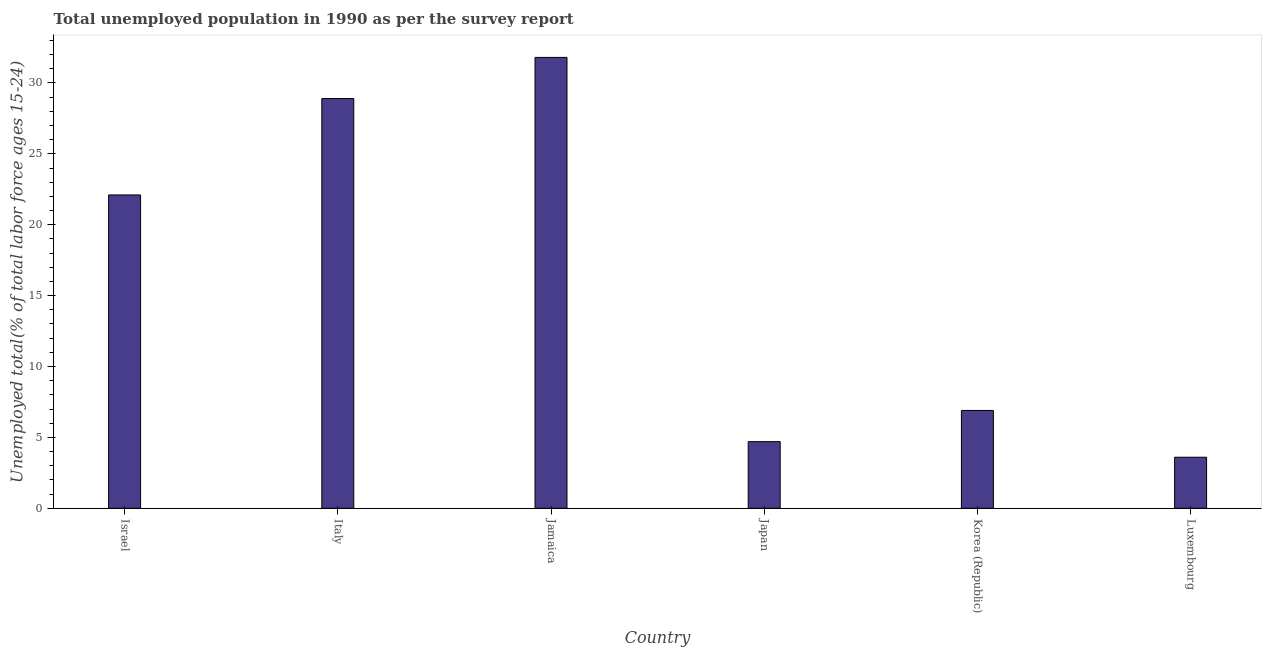Does the graph contain any zero values?
Your answer should be compact. No. Does the graph contain grids?
Your answer should be very brief. No. What is the title of the graph?
Provide a succinct answer. Total unemployed population in 1990 as per the survey report. What is the label or title of the X-axis?
Keep it short and to the point. Country. What is the label or title of the Y-axis?
Your response must be concise. Unemployed total(% of total labor force ages 15-24). What is the unemployed youth in Jamaica?
Provide a short and direct response. 31.8. Across all countries, what is the maximum unemployed youth?
Ensure brevity in your answer.  31.8. Across all countries, what is the minimum unemployed youth?
Provide a succinct answer. 3.6. In which country was the unemployed youth maximum?
Keep it short and to the point. Jamaica. In which country was the unemployed youth minimum?
Your answer should be very brief. Luxembourg. What is the sum of the unemployed youth?
Your response must be concise. 98. What is the difference between the unemployed youth in Japan and Korea (Republic)?
Your answer should be compact. -2.2. What is the average unemployed youth per country?
Your response must be concise. 16.33. What is the median unemployed youth?
Give a very brief answer. 14.5. What is the ratio of the unemployed youth in Italy to that in Korea (Republic)?
Your answer should be very brief. 4.19. Is the unemployed youth in Italy less than that in Japan?
Ensure brevity in your answer.  No. Is the difference between the unemployed youth in Israel and Korea (Republic) greater than the difference between any two countries?
Offer a terse response. No. What is the difference between the highest and the second highest unemployed youth?
Make the answer very short. 2.9. What is the difference between the highest and the lowest unemployed youth?
Provide a succinct answer. 28.2. In how many countries, is the unemployed youth greater than the average unemployed youth taken over all countries?
Provide a succinct answer. 3. How many bars are there?
Ensure brevity in your answer.  6. What is the Unemployed total(% of total labor force ages 15-24) of Israel?
Keep it short and to the point. 22.1. What is the Unemployed total(% of total labor force ages 15-24) in Italy?
Give a very brief answer. 28.9. What is the Unemployed total(% of total labor force ages 15-24) in Jamaica?
Give a very brief answer. 31.8. What is the Unemployed total(% of total labor force ages 15-24) in Japan?
Make the answer very short. 4.7. What is the Unemployed total(% of total labor force ages 15-24) of Korea (Republic)?
Your answer should be very brief. 6.9. What is the Unemployed total(% of total labor force ages 15-24) of Luxembourg?
Keep it short and to the point. 3.6. What is the difference between the Unemployed total(% of total labor force ages 15-24) in Israel and Italy?
Your response must be concise. -6.8. What is the difference between the Unemployed total(% of total labor force ages 15-24) in Israel and Jamaica?
Keep it short and to the point. -9.7. What is the difference between the Unemployed total(% of total labor force ages 15-24) in Israel and Korea (Republic)?
Offer a terse response. 15.2. What is the difference between the Unemployed total(% of total labor force ages 15-24) in Italy and Japan?
Ensure brevity in your answer.  24.2. What is the difference between the Unemployed total(% of total labor force ages 15-24) in Italy and Luxembourg?
Offer a very short reply. 25.3. What is the difference between the Unemployed total(% of total labor force ages 15-24) in Jamaica and Japan?
Your response must be concise. 27.1. What is the difference between the Unemployed total(% of total labor force ages 15-24) in Jamaica and Korea (Republic)?
Keep it short and to the point. 24.9. What is the difference between the Unemployed total(% of total labor force ages 15-24) in Jamaica and Luxembourg?
Offer a very short reply. 28.2. What is the ratio of the Unemployed total(% of total labor force ages 15-24) in Israel to that in Italy?
Your answer should be compact. 0.77. What is the ratio of the Unemployed total(% of total labor force ages 15-24) in Israel to that in Jamaica?
Provide a short and direct response. 0.69. What is the ratio of the Unemployed total(% of total labor force ages 15-24) in Israel to that in Japan?
Offer a very short reply. 4.7. What is the ratio of the Unemployed total(% of total labor force ages 15-24) in Israel to that in Korea (Republic)?
Your answer should be very brief. 3.2. What is the ratio of the Unemployed total(% of total labor force ages 15-24) in Israel to that in Luxembourg?
Your answer should be compact. 6.14. What is the ratio of the Unemployed total(% of total labor force ages 15-24) in Italy to that in Jamaica?
Your response must be concise. 0.91. What is the ratio of the Unemployed total(% of total labor force ages 15-24) in Italy to that in Japan?
Provide a succinct answer. 6.15. What is the ratio of the Unemployed total(% of total labor force ages 15-24) in Italy to that in Korea (Republic)?
Provide a short and direct response. 4.19. What is the ratio of the Unemployed total(% of total labor force ages 15-24) in Italy to that in Luxembourg?
Keep it short and to the point. 8.03. What is the ratio of the Unemployed total(% of total labor force ages 15-24) in Jamaica to that in Japan?
Offer a very short reply. 6.77. What is the ratio of the Unemployed total(% of total labor force ages 15-24) in Jamaica to that in Korea (Republic)?
Make the answer very short. 4.61. What is the ratio of the Unemployed total(% of total labor force ages 15-24) in Jamaica to that in Luxembourg?
Your response must be concise. 8.83. What is the ratio of the Unemployed total(% of total labor force ages 15-24) in Japan to that in Korea (Republic)?
Ensure brevity in your answer.  0.68. What is the ratio of the Unemployed total(% of total labor force ages 15-24) in Japan to that in Luxembourg?
Your response must be concise. 1.31. What is the ratio of the Unemployed total(% of total labor force ages 15-24) in Korea (Republic) to that in Luxembourg?
Give a very brief answer. 1.92. 